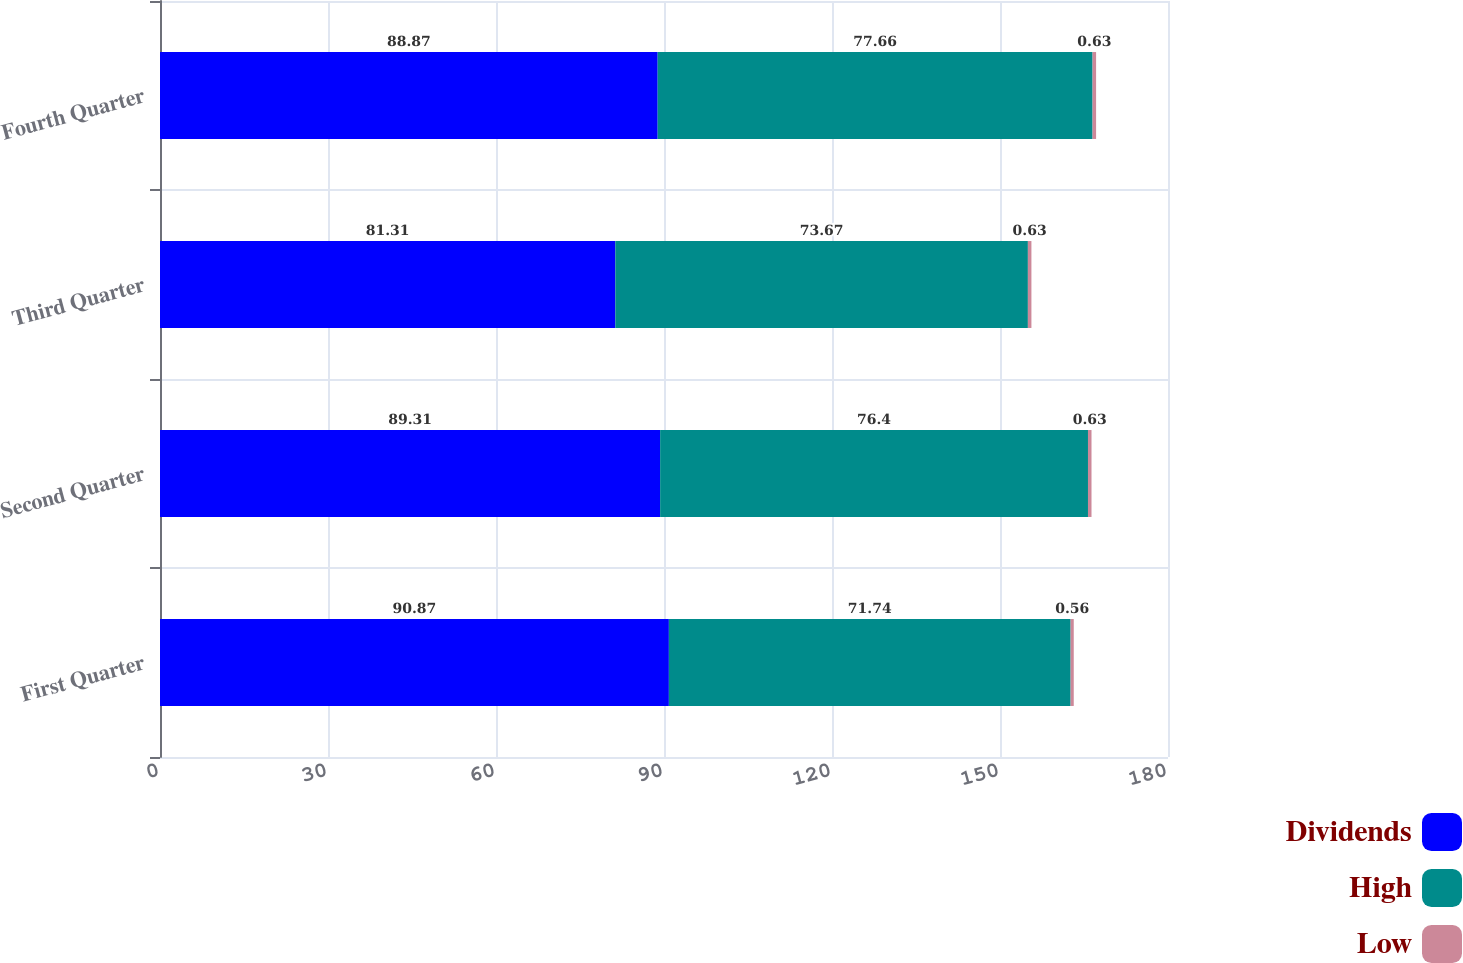Convert chart to OTSL. <chart><loc_0><loc_0><loc_500><loc_500><stacked_bar_chart><ecel><fcel>First Quarter<fcel>Second Quarter<fcel>Third Quarter<fcel>Fourth Quarter<nl><fcel>Dividends<fcel>90.87<fcel>89.31<fcel>81.31<fcel>88.87<nl><fcel>High<fcel>71.74<fcel>76.4<fcel>73.67<fcel>77.66<nl><fcel>Low<fcel>0.56<fcel>0.63<fcel>0.63<fcel>0.63<nl></chart> 